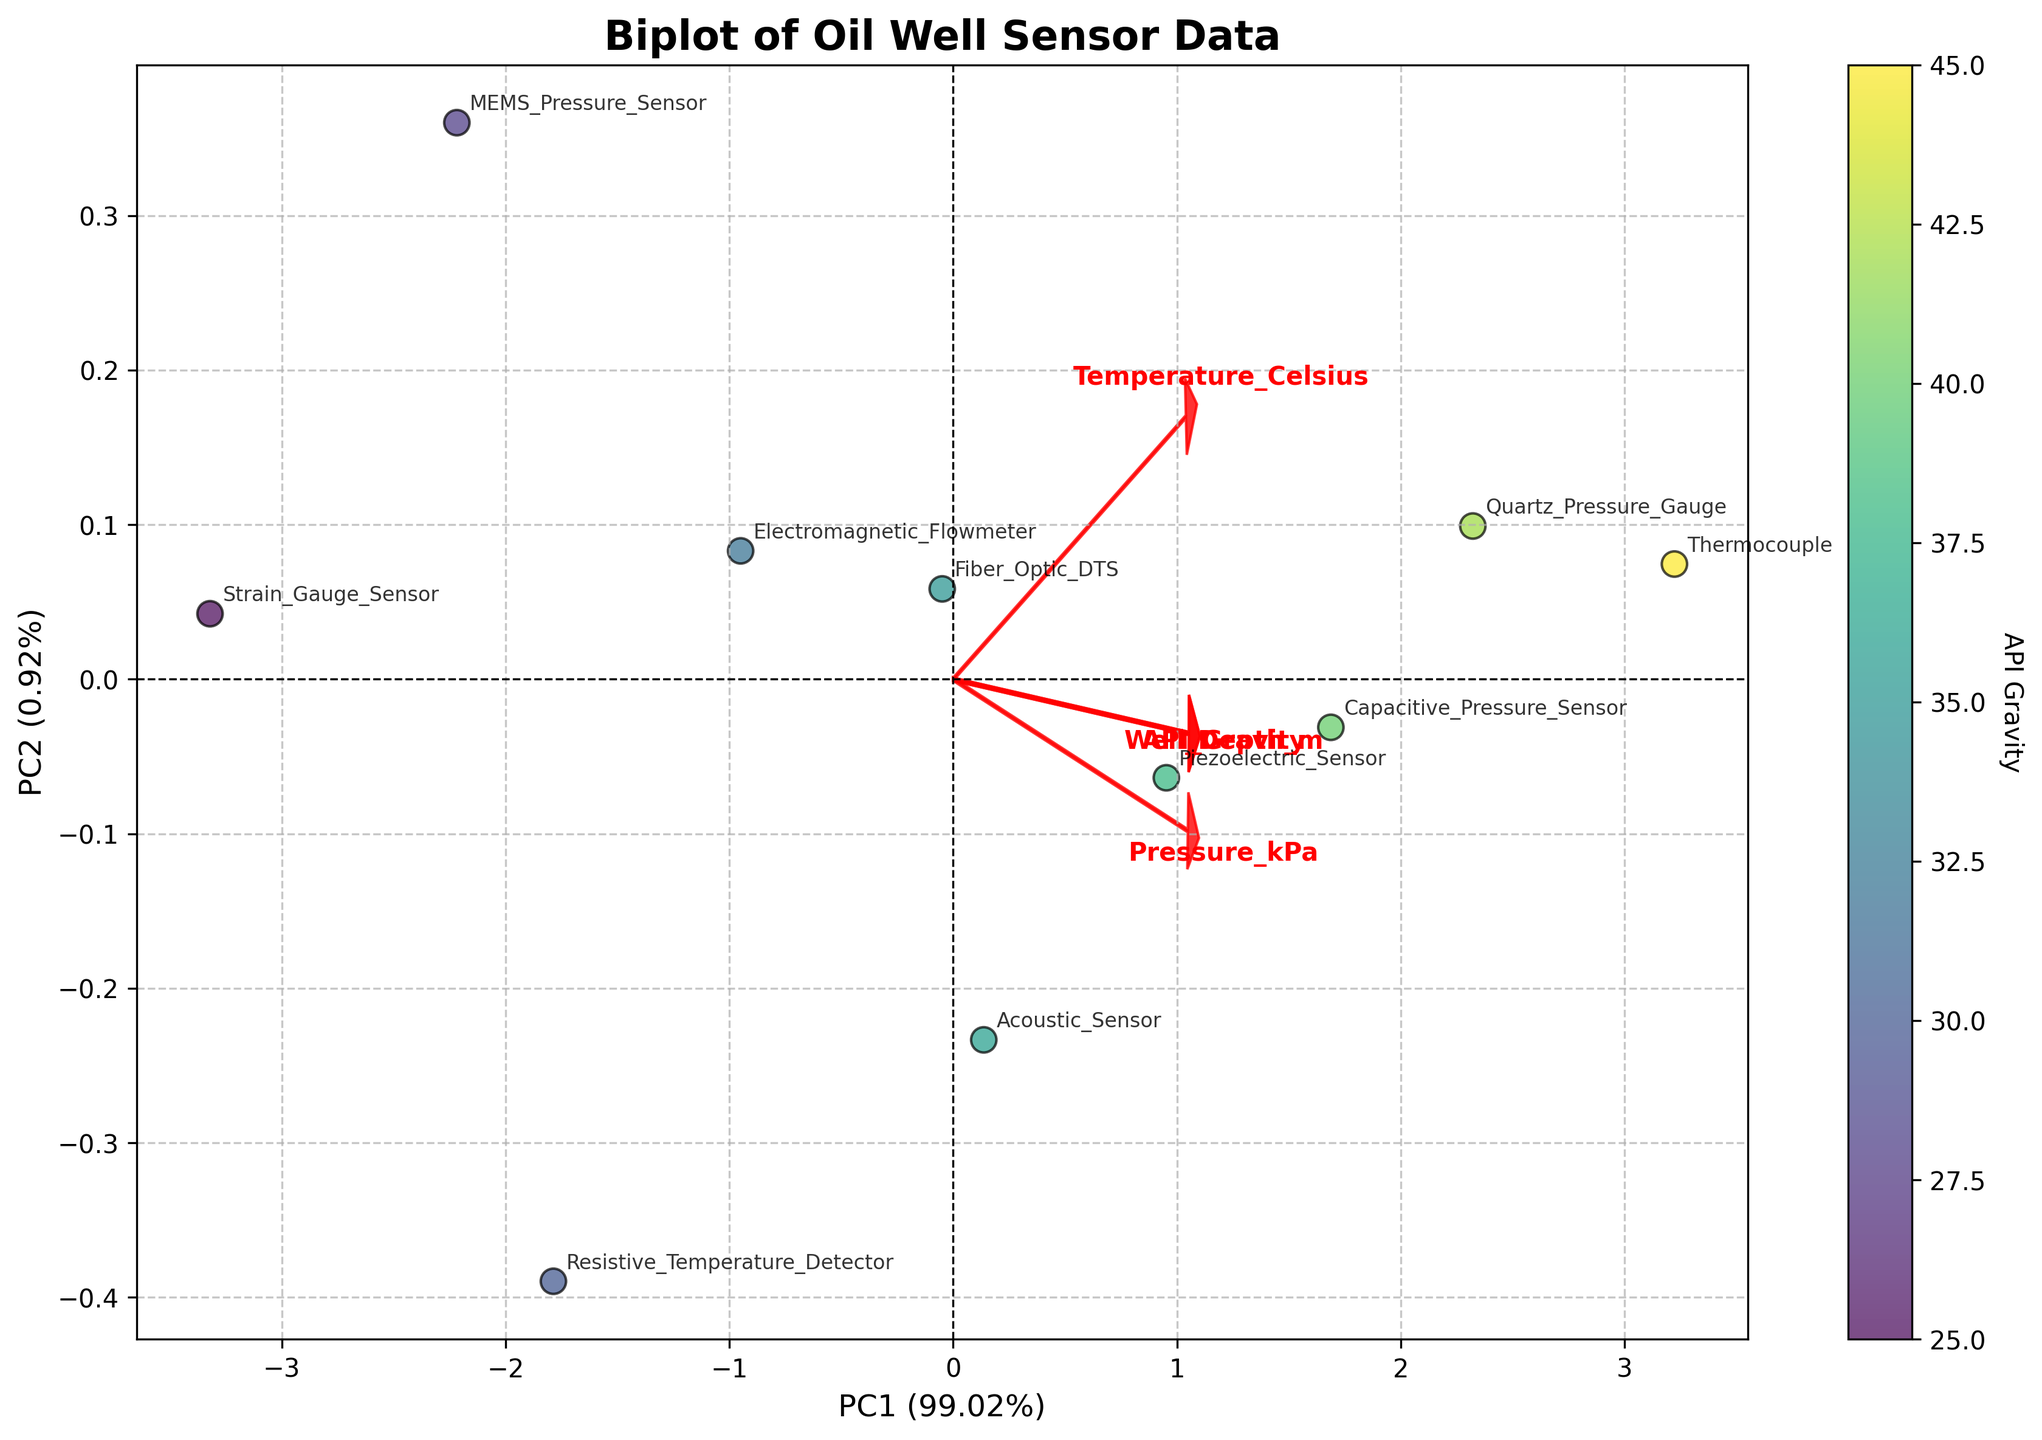What is the title of the plot? The title of the plot is visibly placed at the top center of the figure. It reads "Biplot of Oil Well Sensor Data".
Answer: Biplot of Oil Well Sensor Data Which axis represents the first principal component? The first principal component is represented on the x-axis as indicated by the label "PC1".
Answer: x-axis How many sensor types are represented in the plot? Each sensor type has an annotation in the plot. By counting them, there are ten sensor types.
Answer: 10 What variable is represented by the color gradient on the plot? The color gradient of the data points is explained by the color bar next to the plot, which is labeled "API Gravity".
Answer: API Gravity Which sensor type has the highest API Gravity, and where is it located on the plot? By looking at the color gradient, the sensor type with the darkest color (indicating the highest API Gravity) is "Thermocouple". It is located towards the right side of the plot.
Answer: Thermocouple; right side What relationship between Pressure and Temperature can be inferred from the loadings? The loadings are represented by red arrows, with the "Pressure_kPa" and "Temperature_Celsius" arrows pointing in the same direction, indicating a positive correlation.
Answer: Positive correlation Which sensor type is closest to the origin of the plot? By observing the plot, the sensor type closest to the center (origin) is "Strain_Gauge_Sensor", meaning it is closest to the average of the variables.
Answer: Strain_Gauge_Sensor Which two sensor types are located furthest apart on the plot? The "Thermocouple" is on the far right, and the "Strain_Gauge_Sensor" is on the far left. These two sensor types are the furthest apart.
Answer: Thermocouple and Strain_Gauge_Sensor What is the proportion of variance explained by the first principal component (PC1)? The x-axis label includes the proportion of variance explained by PC1, which is "34.91%".
Answer: 34.91% How do the features 'Well_Depth_m' and 'API_Gravity' relate to each other based on their loadings? On observing the red arrows, the loadings for 'Well_Depth_m' and 'API_Gravity' point in nearly perpendicular directions, indicating little to no correlation.
Answer: Little to no correlation 